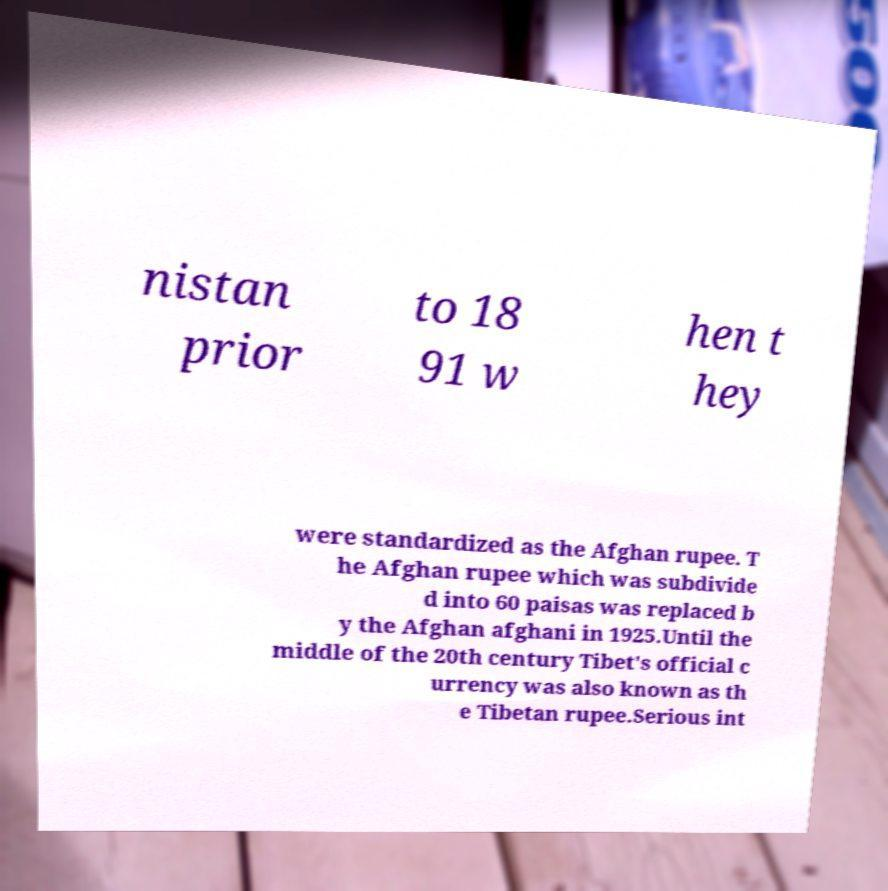There's text embedded in this image that I need extracted. Can you transcribe it verbatim? nistan prior to 18 91 w hen t hey were standardized as the Afghan rupee. T he Afghan rupee which was subdivide d into 60 paisas was replaced b y the Afghan afghani in 1925.Until the middle of the 20th century Tibet's official c urrency was also known as th e Tibetan rupee.Serious int 